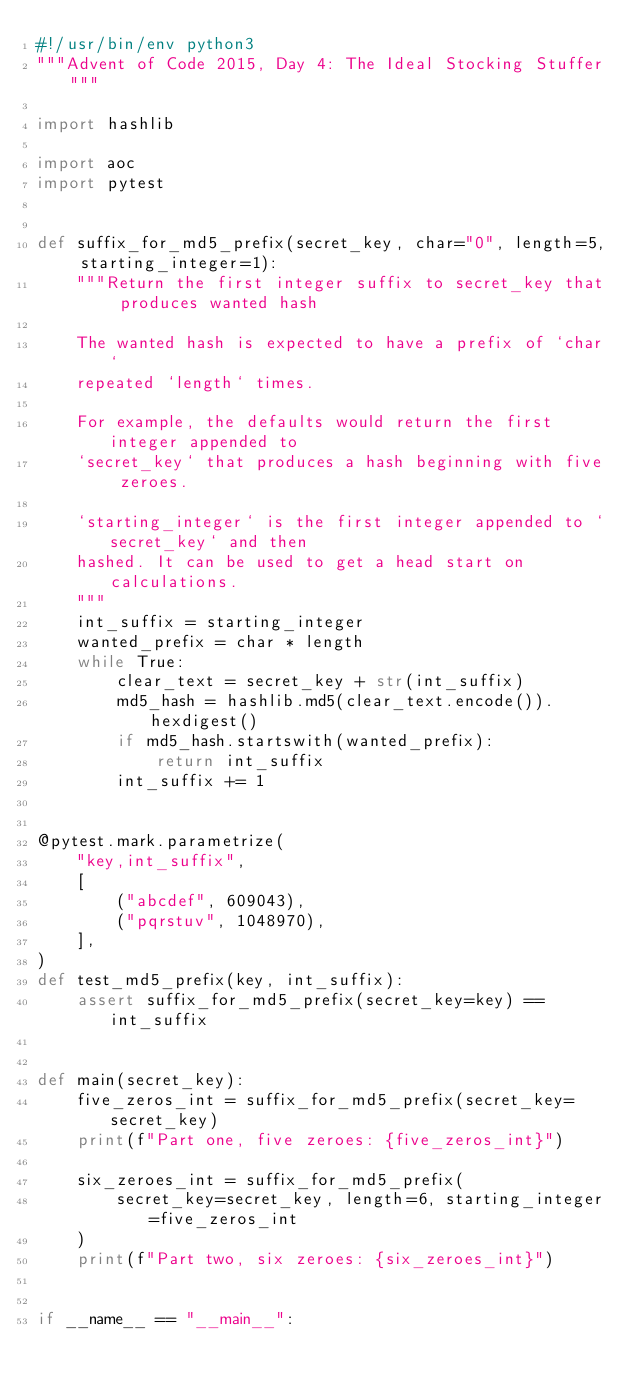<code> <loc_0><loc_0><loc_500><loc_500><_Python_>#!/usr/bin/env python3
"""Advent of Code 2015, Day 4: The Ideal Stocking Stuffer"""

import hashlib

import aoc
import pytest


def suffix_for_md5_prefix(secret_key, char="0", length=5, starting_integer=1):
    """Return the first integer suffix to secret_key that produces wanted hash

    The wanted hash is expected to have a prefix of `char`
    repeated `length` times.

    For example, the defaults would return the first integer appended to
    `secret_key` that produces a hash beginning with five zeroes.

    `starting_integer` is the first integer appended to `secret_key` and then
    hashed. It can be used to get a head start on calculations.
    """
    int_suffix = starting_integer
    wanted_prefix = char * length
    while True:
        clear_text = secret_key + str(int_suffix)
        md5_hash = hashlib.md5(clear_text.encode()).hexdigest()
        if md5_hash.startswith(wanted_prefix):
            return int_suffix
        int_suffix += 1


@pytest.mark.parametrize(
    "key,int_suffix",
    [
        ("abcdef", 609043),
        ("pqrstuv", 1048970),
    ],
)
def test_md5_prefix(key, int_suffix):
    assert suffix_for_md5_prefix(secret_key=key) == int_suffix


def main(secret_key):
    five_zeros_int = suffix_for_md5_prefix(secret_key=secret_key)
    print(f"Part one, five zeroes: {five_zeros_int}")

    six_zeroes_int = suffix_for_md5_prefix(
        secret_key=secret_key, length=6, starting_integer=five_zeros_int
    )
    print(f"Part two, six zeroes: {six_zeroes_int}")


if __name__ == "__main__":</code> 